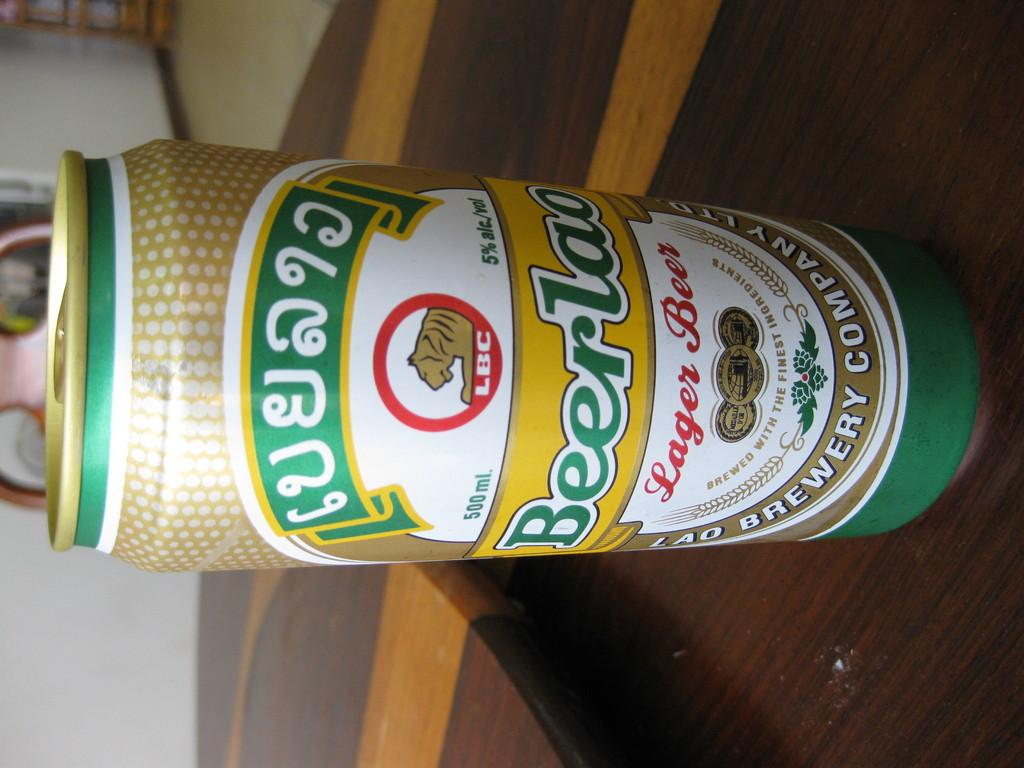<image>
Write a terse but informative summary of the picture. A can of lager beer has an LBC logo at the top. 